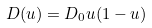<formula> <loc_0><loc_0><loc_500><loc_500>D ( u ) = D _ { 0 } u ( 1 - u )</formula> 